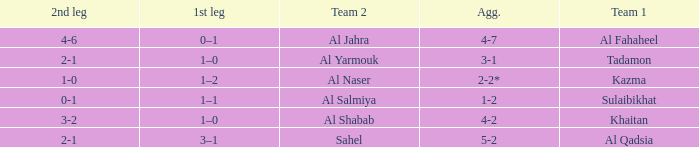What is the name of Team 2 with a Team 1 of Al Qadsia? Sahel. 